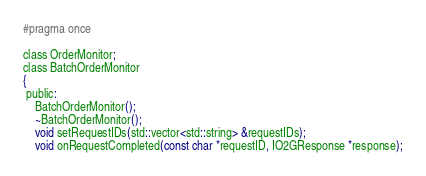Convert code to text. <code><loc_0><loc_0><loc_500><loc_500><_C_>#pragma once

class OrderMonitor;
class BatchOrderMonitor
{
 public:
    BatchOrderMonitor();
    ~BatchOrderMonitor();
    void setRequestIDs(std::vector<std::string> &requestIDs);
    void onRequestCompleted(const char *requestID, IO2GResponse *response);</code> 